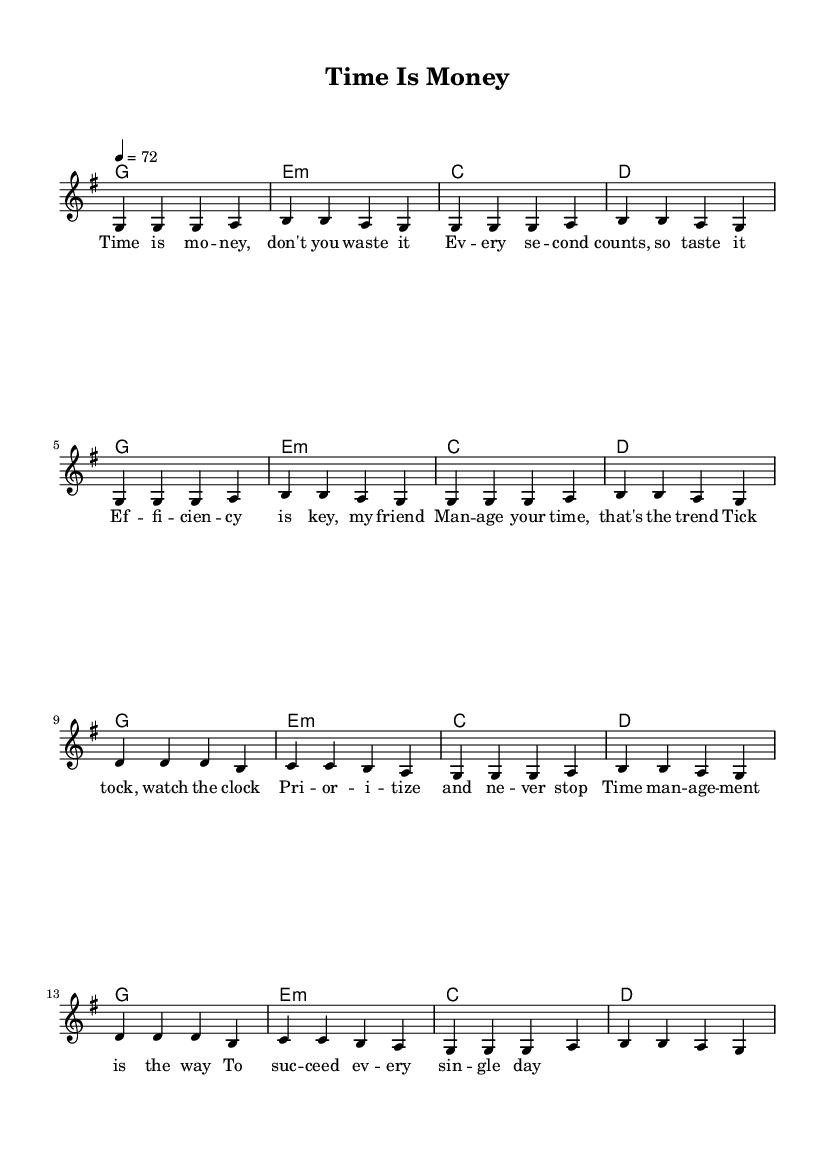What is the key signature of this music? The key signature is G major, which has one sharp (F#).
Answer: G major What is the time signature of this piece? The time signature is 4/4, meaning there are four beats in each measure.
Answer: 4/4 What is the tempo marking of this score? The tempo marking indicates a speed of 72 beats per minute.
Answer: 72 How many measures are in the verse section? The verse section consists of four measures, repeating twice.
Answer: 8 measures What is the primary theme of the lyrics? The lyrics focus on time management and the importance of efficiency in life.
Answer: Time management What chord is used for the chorus? The primary chord used in the chorus is D major.
Answer: D major How does the reggae style influence the rhythm of the piece? The reggae style typically features off-beat accents and a laid-back feel, which is reflected in the rhythm and lyrics emphasizing time management with a relaxed groove.
Answer: Off-beat accents 